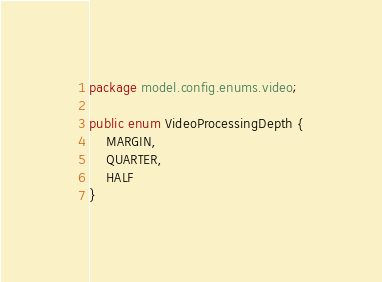<code> <loc_0><loc_0><loc_500><loc_500><_Java_>package model.config.enums.video;

public enum VideoProcessingDepth {
    MARGIN,
    QUARTER,
    HALF
}
</code> 